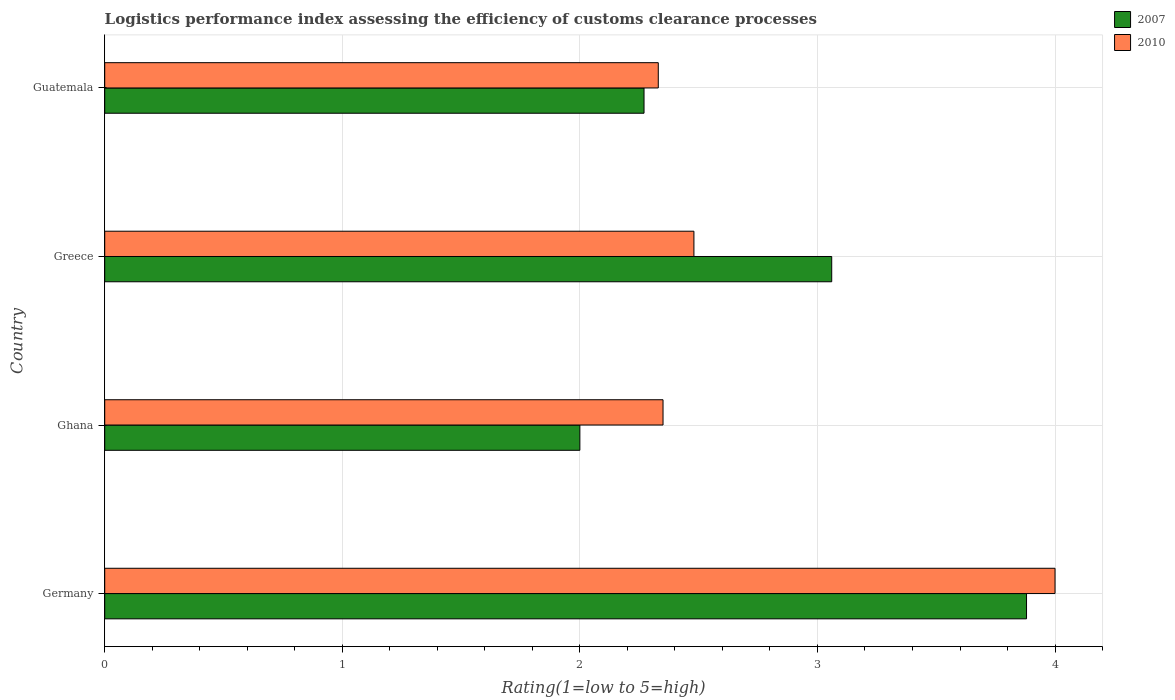How many different coloured bars are there?
Give a very brief answer. 2. Are the number of bars on each tick of the Y-axis equal?
Your response must be concise. Yes. What is the label of the 2nd group of bars from the top?
Keep it short and to the point. Greece. In how many cases, is the number of bars for a given country not equal to the number of legend labels?
Your answer should be very brief. 0. What is the Logistic performance index in 2007 in Guatemala?
Make the answer very short. 2.27. Across all countries, what is the minimum Logistic performance index in 2010?
Offer a very short reply. 2.33. In which country was the Logistic performance index in 2010 minimum?
Offer a very short reply. Guatemala. What is the total Logistic performance index in 2010 in the graph?
Ensure brevity in your answer.  11.16. What is the difference between the Logistic performance index in 2007 in Ghana and that in Greece?
Ensure brevity in your answer.  -1.06. What is the difference between the Logistic performance index in 2007 in Greece and the Logistic performance index in 2010 in Guatemala?
Offer a very short reply. 0.73. What is the average Logistic performance index in 2007 per country?
Offer a very short reply. 2.8. What is the difference between the Logistic performance index in 2007 and Logistic performance index in 2010 in Greece?
Your answer should be compact. 0.58. What is the ratio of the Logistic performance index in 2007 in Greece to that in Guatemala?
Your response must be concise. 1.35. What is the difference between the highest and the second highest Logistic performance index in 2007?
Provide a short and direct response. 0.82. What is the difference between the highest and the lowest Logistic performance index in 2010?
Give a very brief answer. 1.67. In how many countries, is the Logistic performance index in 2010 greater than the average Logistic performance index in 2010 taken over all countries?
Your answer should be compact. 1. Is the sum of the Logistic performance index in 2010 in Germany and Guatemala greater than the maximum Logistic performance index in 2007 across all countries?
Give a very brief answer. Yes. What does the 1st bar from the bottom in Greece represents?
Offer a very short reply. 2007. How many bars are there?
Your answer should be very brief. 8. Are all the bars in the graph horizontal?
Provide a short and direct response. Yes. Are the values on the major ticks of X-axis written in scientific E-notation?
Your answer should be very brief. No. Does the graph contain grids?
Offer a terse response. Yes. How are the legend labels stacked?
Provide a short and direct response. Vertical. What is the title of the graph?
Your answer should be compact. Logistics performance index assessing the efficiency of customs clearance processes. Does "1999" appear as one of the legend labels in the graph?
Ensure brevity in your answer.  No. What is the label or title of the X-axis?
Your response must be concise. Rating(1=low to 5=high). What is the Rating(1=low to 5=high) in 2007 in Germany?
Give a very brief answer. 3.88. What is the Rating(1=low to 5=high) in 2007 in Ghana?
Ensure brevity in your answer.  2. What is the Rating(1=low to 5=high) in 2010 in Ghana?
Offer a very short reply. 2.35. What is the Rating(1=low to 5=high) in 2007 in Greece?
Ensure brevity in your answer.  3.06. What is the Rating(1=low to 5=high) in 2010 in Greece?
Ensure brevity in your answer.  2.48. What is the Rating(1=low to 5=high) of 2007 in Guatemala?
Make the answer very short. 2.27. What is the Rating(1=low to 5=high) in 2010 in Guatemala?
Offer a terse response. 2.33. Across all countries, what is the maximum Rating(1=low to 5=high) in 2007?
Your answer should be very brief. 3.88. Across all countries, what is the minimum Rating(1=low to 5=high) in 2010?
Provide a succinct answer. 2.33. What is the total Rating(1=low to 5=high) in 2007 in the graph?
Make the answer very short. 11.21. What is the total Rating(1=low to 5=high) in 2010 in the graph?
Offer a terse response. 11.16. What is the difference between the Rating(1=low to 5=high) in 2007 in Germany and that in Ghana?
Provide a short and direct response. 1.88. What is the difference between the Rating(1=low to 5=high) in 2010 in Germany and that in Ghana?
Make the answer very short. 1.65. What is the difference between the Rating(1=low to 5=high) in 2007 in Germany and that in Greece?
Provide a short and direct response. 0.82. What is the difference between the Rating(1=low to 5=high) in 2010 in Germany and that in Greece?
Your response must be concise. 1.52. What is the difference between the Rating(1=low to 5=high) of 2007 in Germany and that in Guatemala?
Keep it short and to the point. 1.61. What is the difference between the Rating(1=low to 5=high) of 2010 in Germany and that in Guatemala?
Your answer should be very brief. 1.67. What is the difference between the Rating(1=low to 5=high) of 2007 in Ghana and that in Greece?
Offer a terse response. -1.06. What is the difference between the Rating(1=low to 5=high) in 2010 in Ghana and that in Greece?
Keep it short and to the point. -0.13. What is the difference between the Rating(1=low to 5=high) in 2007 in Ghana and that in Guatemala?
Provide a succinct answer. -0.27. What is the difference between the Rating(1=low to 5=high) of 2010 in Ghana and that in Guatemala?
Your answer should be compact. 0.02. What is the difference between the Rating(1=low to 5=high) in 2007 in Greece and that in Guatemala?
Offer a terse response. 0.79. What is the difference between the Rating(1=low to 5=high) of 2007 in Germany and the Rating(1=low to 5=high) of 2010 in Ghana?
Offer a very short reply. 1.53. What is the difference between the Rating(1=low to 5=high) in 2007 in Germany and the Rating(1=low to 5=high) in 2010 in Guatemala?
Make the answer very short. 1.55. What is the difference between the Rating(1=low to 5=high) in 2007 in Ghana and the Rating(1=low to 5=high) in 2010 in Greece?
Ensure brevity in your answer.  -0.48. What is the difference between the Rating(1=low to 5=high) of 2007 in Ghana and the Rating(1=low to 5=high) of 2010 in Guatemala?
Provide a short and direct response. -0.33. What is the difference between the Rating(1=low to 5=high) of 2007 in Greece and the Rating(1=low to 5=high) of 2010 in Guatemala?
Make the answer very short. 0.73. What is the average Rating(1=low to 5=high) of 2007 per country?
Provide a short and direct response. 2.8. What is the average Rating(1=low to 5=high) in 2010 per country?
Keep it short and to the point. 2.79. What is the difference between the Rating(1=low to 5=high) in 2007 and Rating(1=low to 5=high) in 2010 in Germany?
Offer a very short reply. -0.12. What is the difference between the Rating(1=low to 5=high) in 2007 and Rating(1=low to 5=high) in 2010 in Ghana?
Your answer should be compact. -0.35. What is the difference between the Rating(1=low to 5=high) in 2007 and Rating(1=low to 5=high) in 2010 in Greece?
Your answer should be compact. 0.58. What is the difference between the Rating(1=low to 5=high) of 2007 and Rating(1=low to 5=high) of 2010 in Guatemala?
Ensure brevity in your answer.  -0.06. What is the ratio of the Rating(1=low to 5=high) of 2007 in Germany to that in Ghana?
Ensure brevity in your answer.  1.94. What is the ratio of the Rating(1=low to 5=high) of 2010 in Germany to that in Ghana?
Give a very brief answer. 1.7. What is the ratio of the Rating(1=low to 5=high) of 2007 in Germany to that in Greece?
Keep it short and to the point. 1.27. What is the ratio of the Rating(1=low to 5=high) of 2010 in Germany to that in Greece?
Your answer should be very brief. 1.61. What is the ratio of the Rating(1=low to 5=high) of 2007 in Germany to that in Guatemala?
Make the answer very short. 1.71. What is the ratio of the Rating(1=low to 5=high) in 2010 in Germany to that in Guatemala?
Your answer should be very brief. 1.72. What is the ratio of the Rating(1=low to 5=high) in 2007 in Ghana to that in Greece?
Your answer should be very brief. 0.65. What is the ratio of the Rating(1=low to 5=high) of 2010 in Ghana to that in Greece?
Give a very brief answer. 0.95. What is the ratio of the Rating(1=low to 5=high) in 2007 in Ghana to that in Guatemala?
Make the answer very short. 0.88. What is the ratio of the Rating(1=low to 5=high) in 2010 in Ghana to that in Guatemala?
Offer a very short reply. 1.01. What is the ratio of the Rating(1=low to 5=high) of 2007 in Greece to that in Guatemala?
Offer a very short reply. 1.35. What is the ratio of the Rating(1=low to 5=high) in 2010 in Greece to that in Guatemala?
Keep it short and to the point. 1.06. What is the difference between the highest and the second highest Rating(1=low to 5=high) of 2007?
Offer a terse response. 0.82. What is the difference between the highest and the second highest Rating(1=low to 5=high) of 2010?
Keep it short and to the point. 1.52. What is the difference between the highest and the lowest Rating(1=low to 5=high) in 2007?
Offer a very short reply. 1.88. What is the difference between the highest and the lowest Rating(1=low to 5=high) of 2010?
Keep it short and to the point. 1.67. 